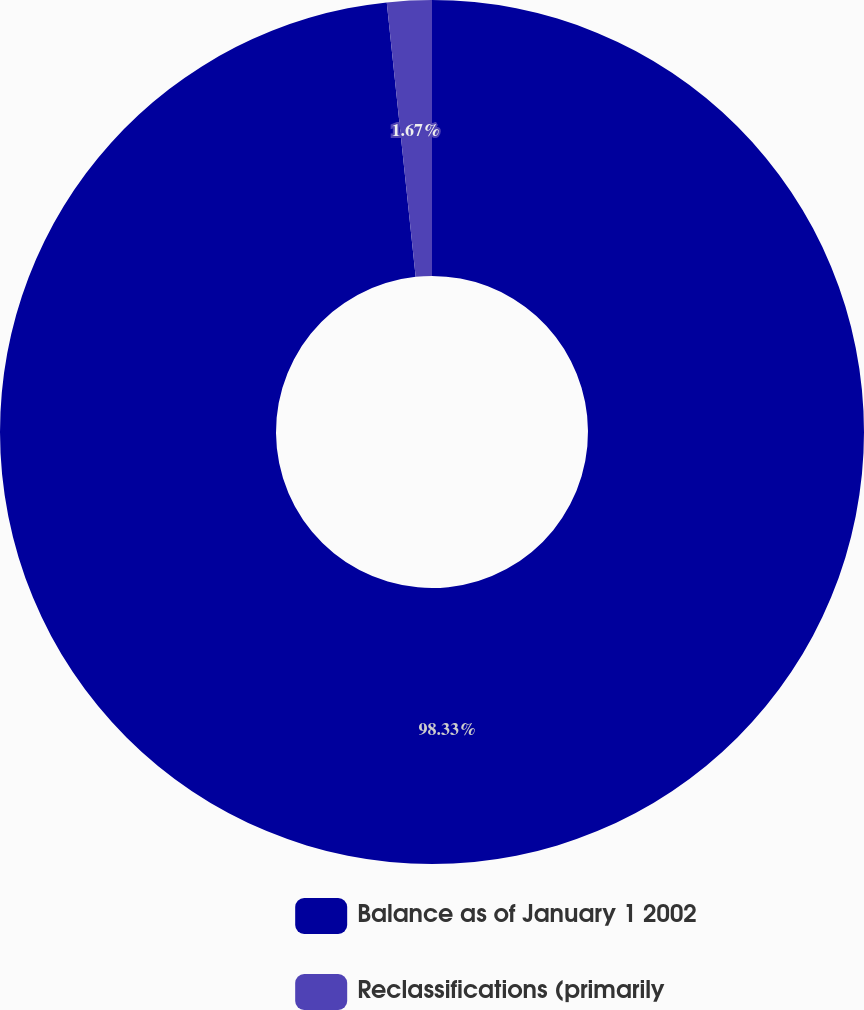<chart> <loc_0><loc_0><loc_500><loc_500><pie_chart><fcel>Balance as of January 1 2002<fcel>Reclassifications (primarily<nl><fcel>98.33%<fcel>1.67%<nl></chart> 